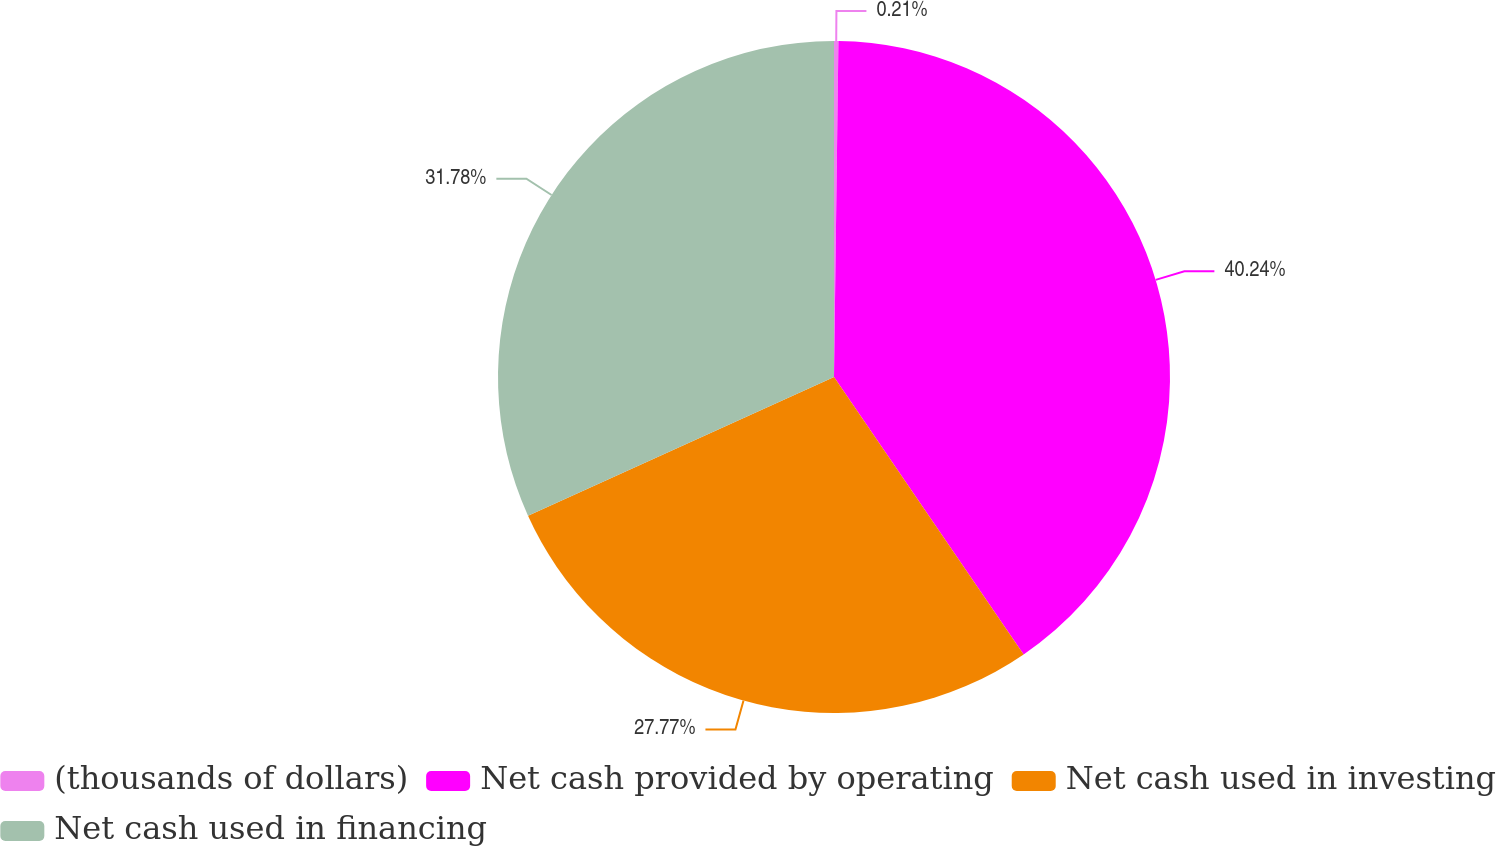<chart> <loc_0><loc_0><loc_500><loc_500><pie_chart><fcel>(thousands of dollars)<fcel>Net cash provided by operating<fcel>Net cash used in investing<fcel>Net cash used in financing<nl><fcel>0.21%<fcel>40.25%<fcel>27.77%<fcel>31.78%<nl></chart> 